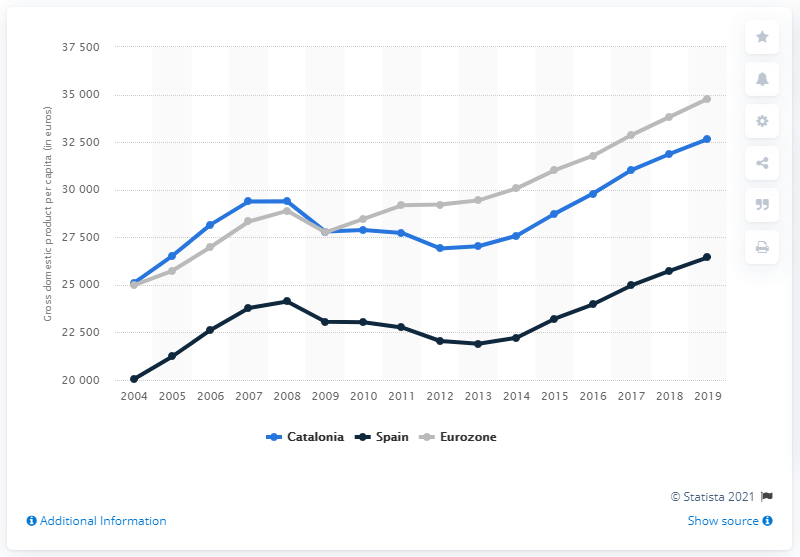Point out several critical features in this image. The estimated GDP per capita of all Europe and Central Asia in 2017 was 23,220. 